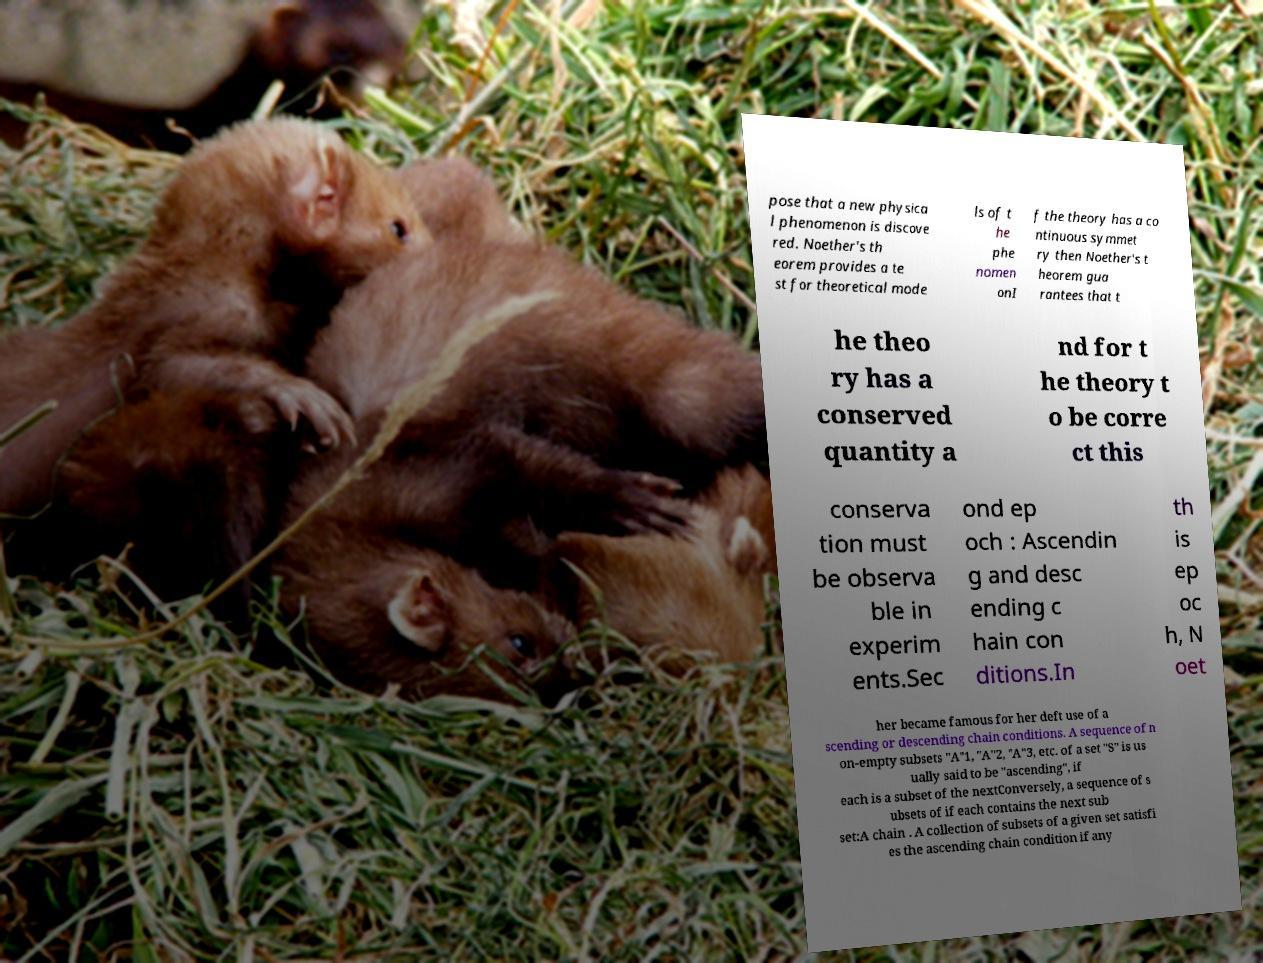What messages or text are displayed in this image? I need them in a readable, typed format. pose that a new physica l phenomenon is discove red. Noether's th eorem provides a te st for theoretical mode ls of t he phe nomen onI f the theory has a co ntinuous symmet ry then Noether's t heorem gua rantees that t he theo ry has a conserved quantity a nd for t he theory t o be corre ct this conserva tion must be observa ble in experim ents.Sec ond ep och : Ascendin g and desc ending c hain con ditions.In th is ep oc h, N oet her became famous for her deft use of a scending or descending chain conditions. A sequence of n on-empty subsets "A"1, "A"2, "A"3, etc. of a set "S" is us ually said to be "ascending", if each is a subset of the nextConversely, a sequence of s ubsets of if each contains the next sub set:A chain . A collection of subsets of a given set satisfi es the ascending chain condition if any 